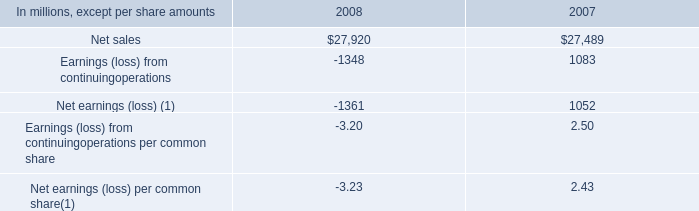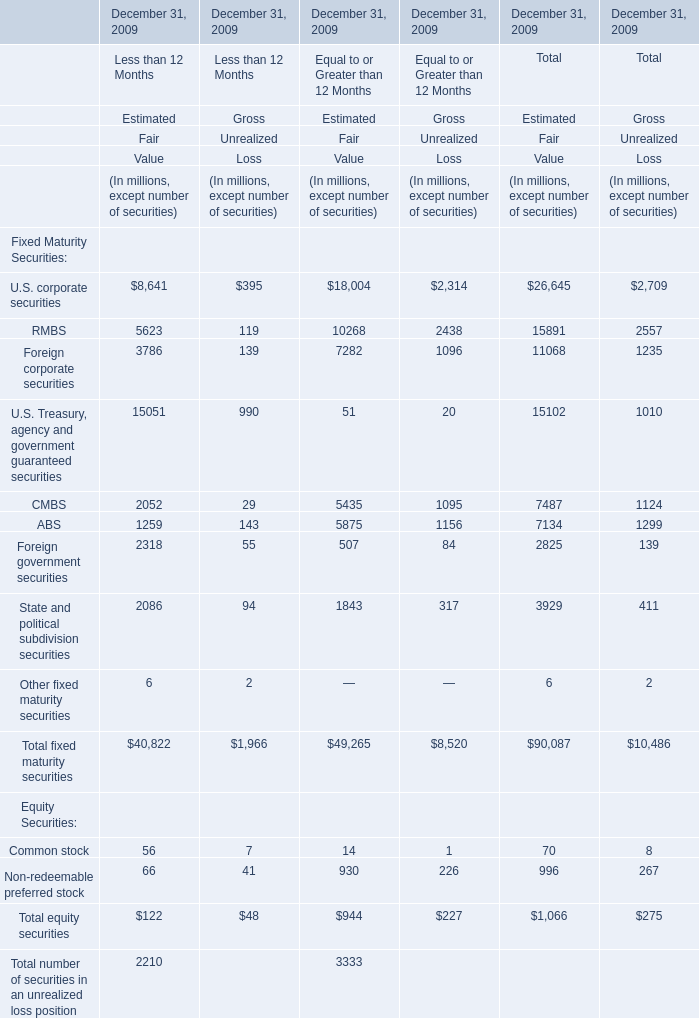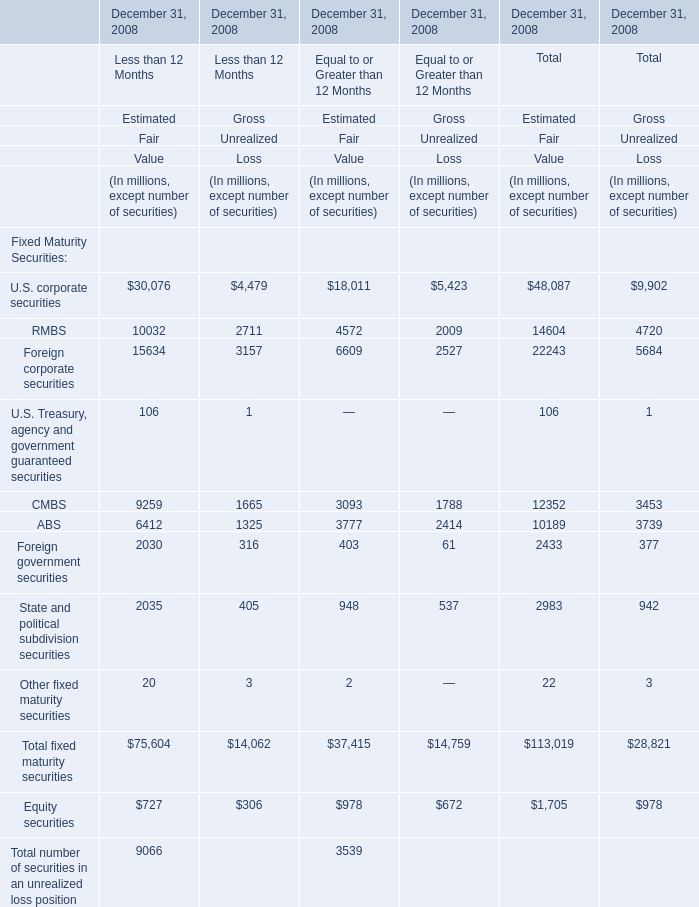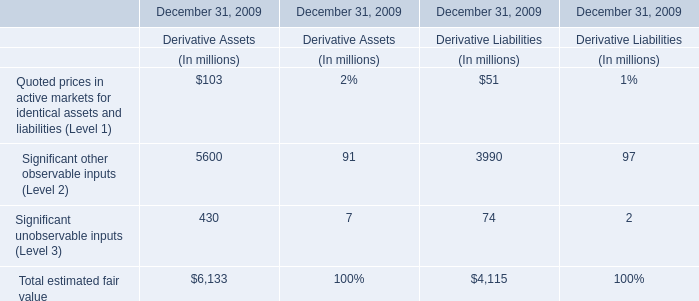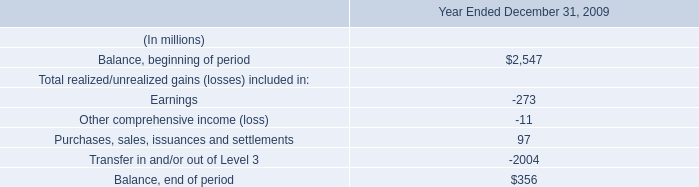what was the ratio of the purchase composition international paper purchased 50% ( 50 % ) of ilim holding s.a for the cash to the notes notes parables 
Computations: (545 / 75)
Answer: 7.26667. 